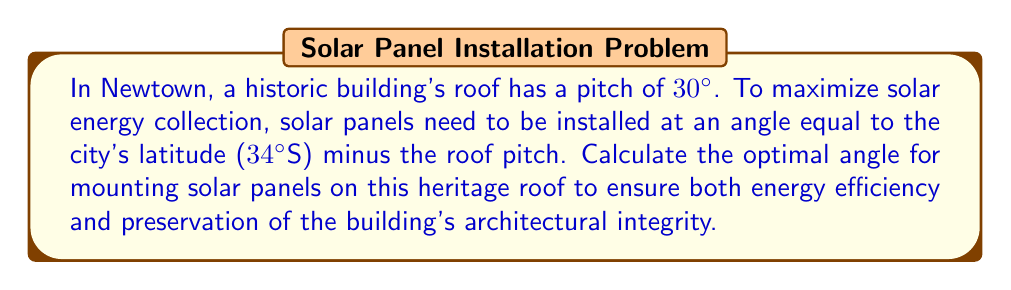What is the answer to this math problem? Let's approach this step-by-step:

1) We know that for maximum solar energy collection, solar panels should be installed at an angle equal to the latitude of the location.

2) Newtown's latitude is given as 34°S.

3) The optimal angle for flat roofs would be:
   $$ \text{Optimal Angle (flat roof)} = 34° $$

4) However, the heritage building's roof already has a pitch of 30°.

5) To account for this existing pitch, we need to subtract it from the optimal angle:
   $$ \text{Optimal Angle (pitched roof)} = \text{Latitude} - \text{Roof Pitch} $$

6) Substituting the values:
   $$ \text{Optimal Angle} = 34° - 30° = 4° $$

7) Therefore, the solar panels should be mounted at a 4° angle relative to the roof surface.

[asy]
import geometry;

size(200);
pair A = (0,0), B = (5,0), C = (2.5,2);
draw(A--B--C--cycle);
label("30°", (4,0.5), E);
draw((2.5,2)--(2.5,2.3));
draw((2.3,2.3)--(2.7,2.3));
label("4°", (2.7,2.2), E);
label("Roof", (2.5,0.7), S);
label("Solar Panel", (3.5,2.2), N);
[/asy]

This angle ensures that the panels are optimally positioned for solar energy collection while minimizing visual impact on the heritage roof's appearance.
Answer: 4° 